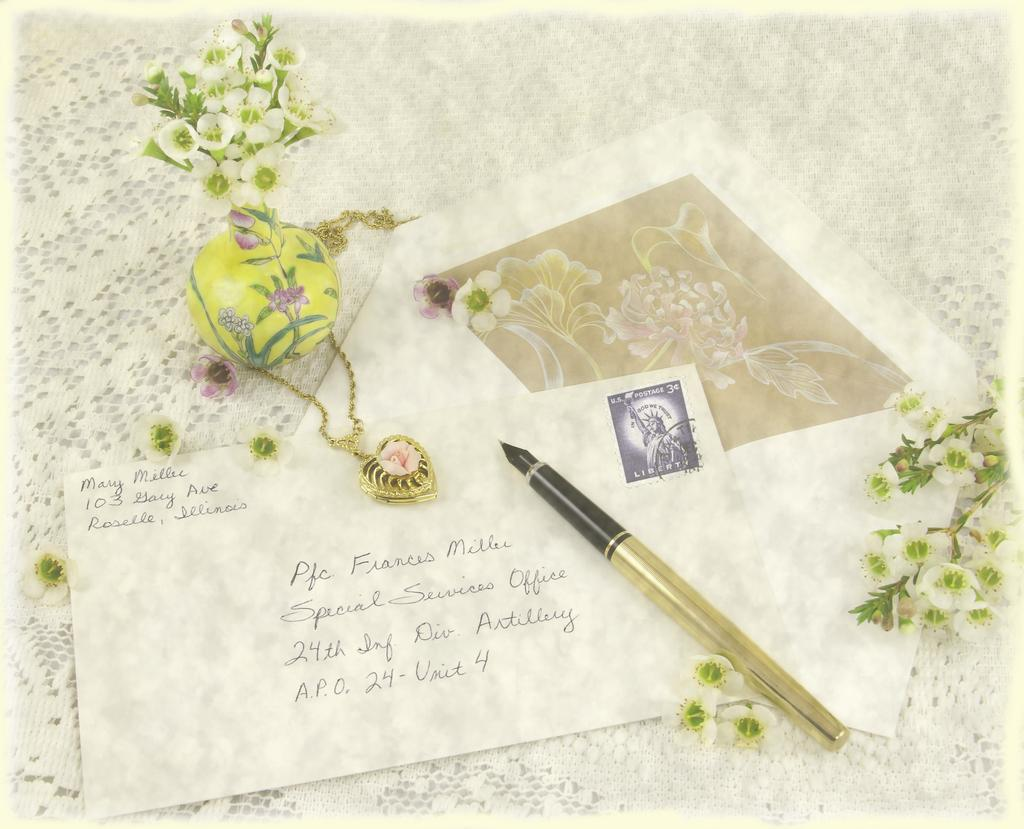<image>
Summarize the visual content of the image. Mary is sending a card to Professor Millec. 